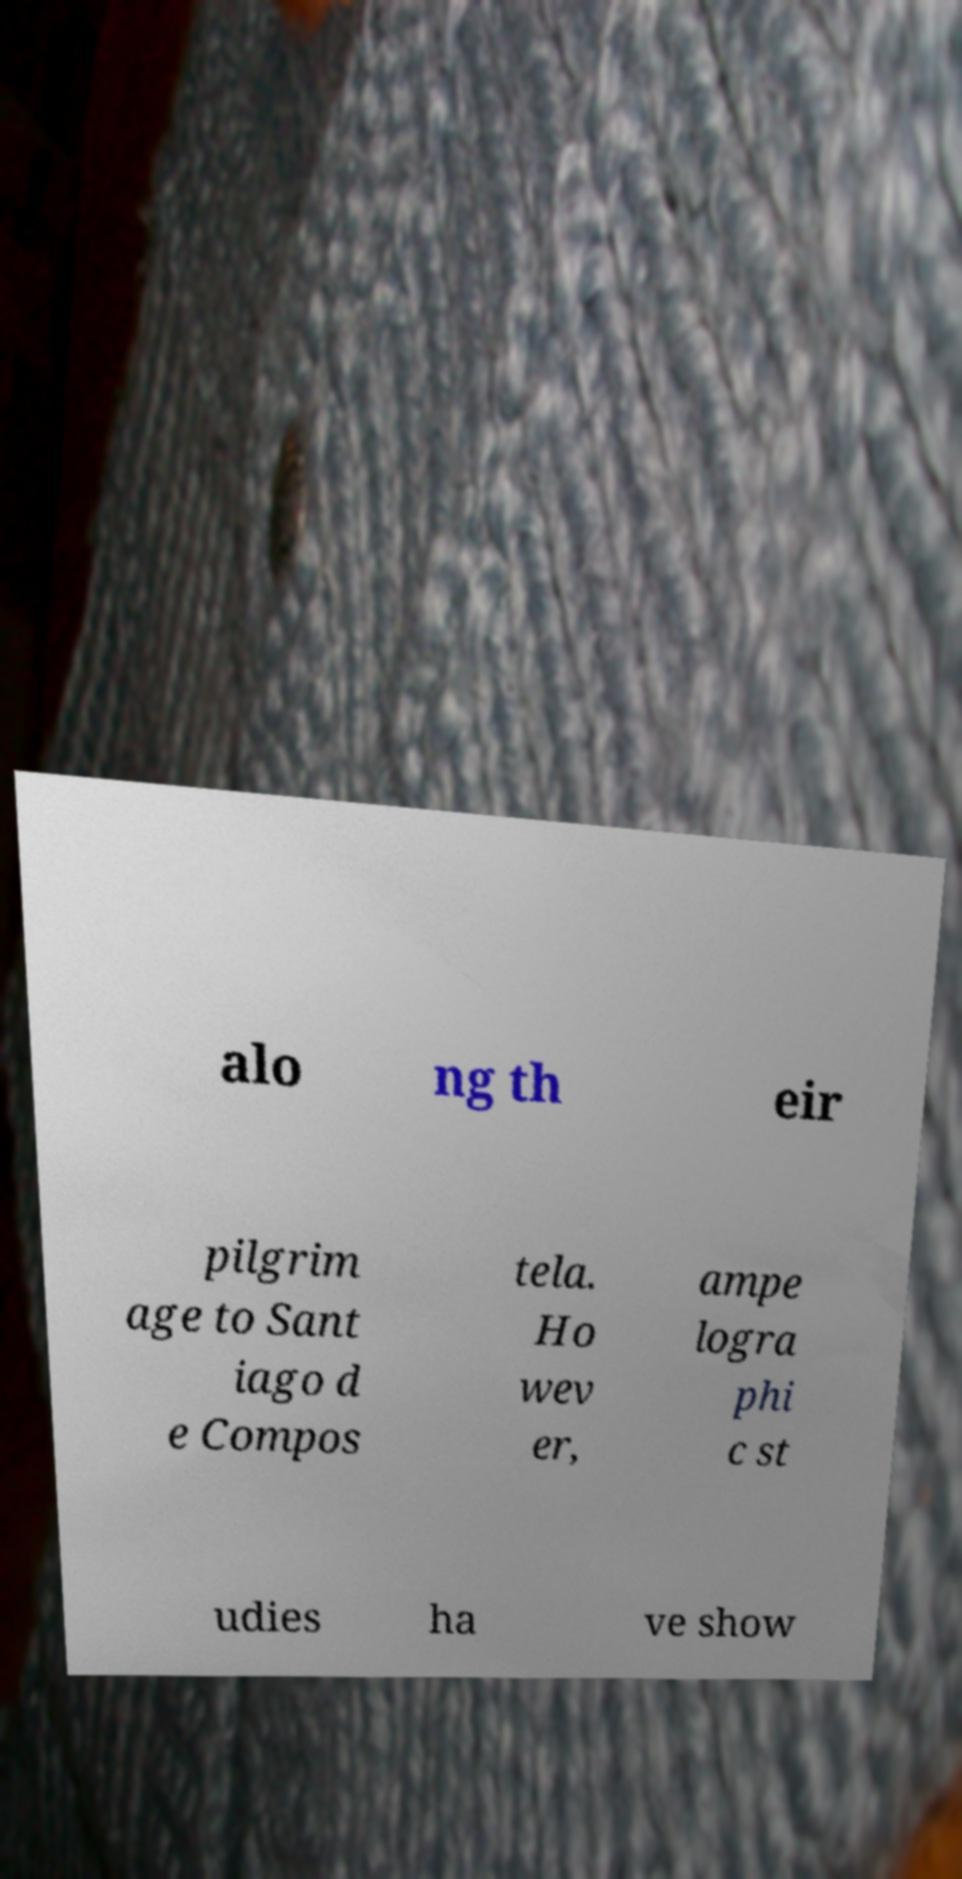I need the written content from this picture converted into text. Can you do that? alo ng th eir pilgrim age to Sant iago d e Compos tela. Ho wev er, ampe logra phi c st udies ha ve show 